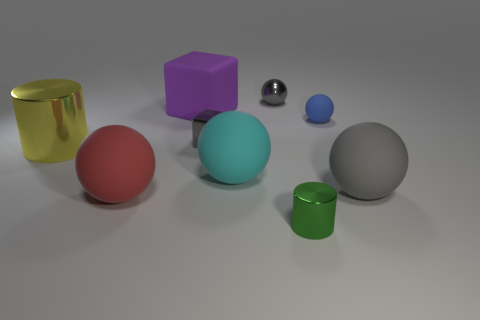There is a small metal thing that is the same shape as the big gray rubber object; what is its color?
Offer a very short reply. Gray. What number of metallic things are the same color as the tiny metallic block?
Ensure brevity in your answer.  1. What is the color of the big object right of the metal cylinder that is in front of the metallic cylinder behind the tiny green shiny thing?
Offer a very short reply. Gray. Does the big red thing have the same material as the green object?
Offer a terse response. No. Is the shape of the yellow object the same as the big red matte thing?
Ensure brevity in your answer.  No. Is the number of big things right of the blue sphere the same as the number of tiny metallic cylinders that are left of the small metallic sphere?
Offer a terse response. No. What is the color of the cube that is the same material as the red sphere?
Your answer should be very brief. Purple. What number of big cylinders have the same material as the large yellow thing?
Offer a terse response. 0. Do the big thing that is to the right of the green cylinder and the small metal cube have the same color?
Keep it short and to the point. Yes. How many gray matte things have the same shape as the large red rubber object?
Offer a very short reply. 1. 